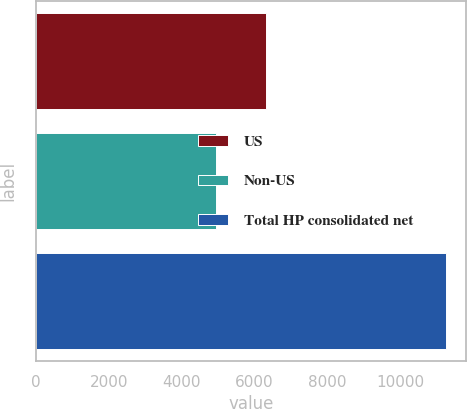Convert chart to OTSL. <chart><loc_0><loc_0><loc_500><loc_500><bar_chart><fcel>US<fcel>Non-US<fcel>Total HP consolidated net<nl><fcel>6316<fcel>4946<fcel>11262<nl></chart> 